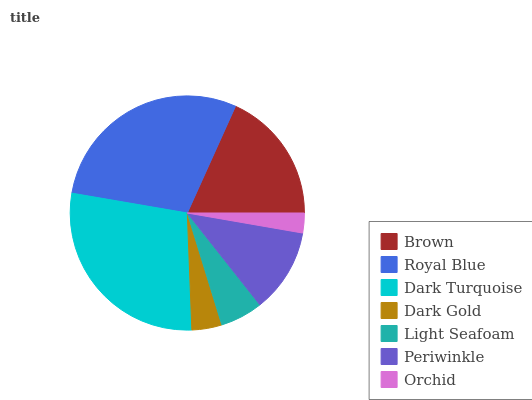Is Orchid the minimum?
Answer yes or no. Yes. Is Royal Blue the maximum?
Answer yes or no. Yes. Is Dark Turquoise the minimum?
Answer yes or no. No. Is Dark Turquoise the maximum?
Answer yes or no. No. Is Royal Blue greater than Dark Turquoise?
Answer yes or no. Yes. Is Dark Turquoise less than Royal Blue?
Answer yes or no. Yes. Is Dark Turquoise greater than Royal Blue?
Answer yes or no. No. Is Royal Blue less than Dark Turquoise?
Answer yes or no. No. Is Periwinkle the high median?
Answer yes or no. Yes. Is Periwinkle the low median?
Answer yes or no. Yes. Is Royal Blue the high median?
Answer yes or no. No. Is Royal Blue the low median?
Answer yes or no. No. 